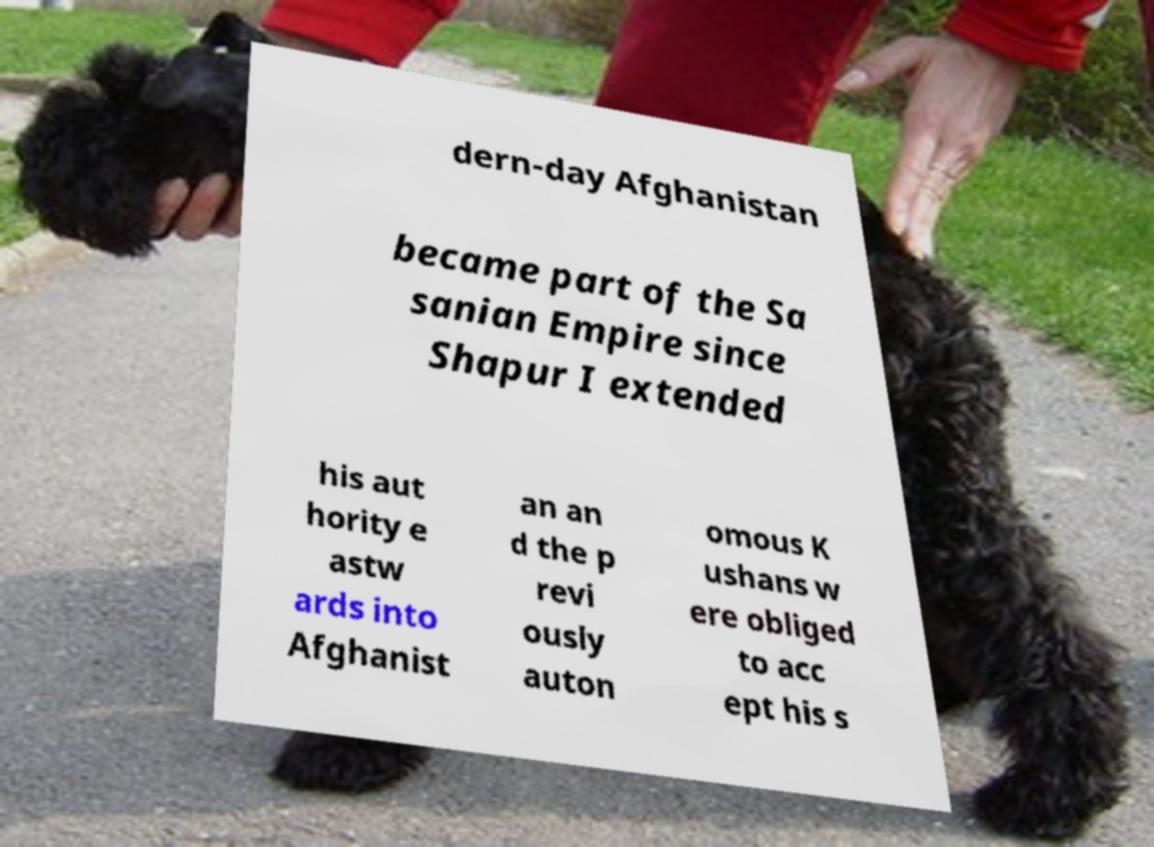What messages or text are displayed in this image? I need them in a readable, typed format. dern-day Afghanistan became part of the Sa sanian Empire since Shapur I extended his aut hority e astw ards into Afghanist an an d the p revi ously auton omous K ushans w ere obliged to acc ept his s 